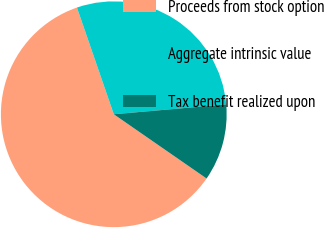Convert chart to OTSL. <chart><loc_0><loc_0><loc_500><loc_500><pie_chart><fcel>Proceeds from stock option<fcel>Aggregate intrinsic value<fcel>Tax benefit realized upon<nl><fcel>60.07%<fcel>28.9%<fcel>11.03%<nl></chart> 